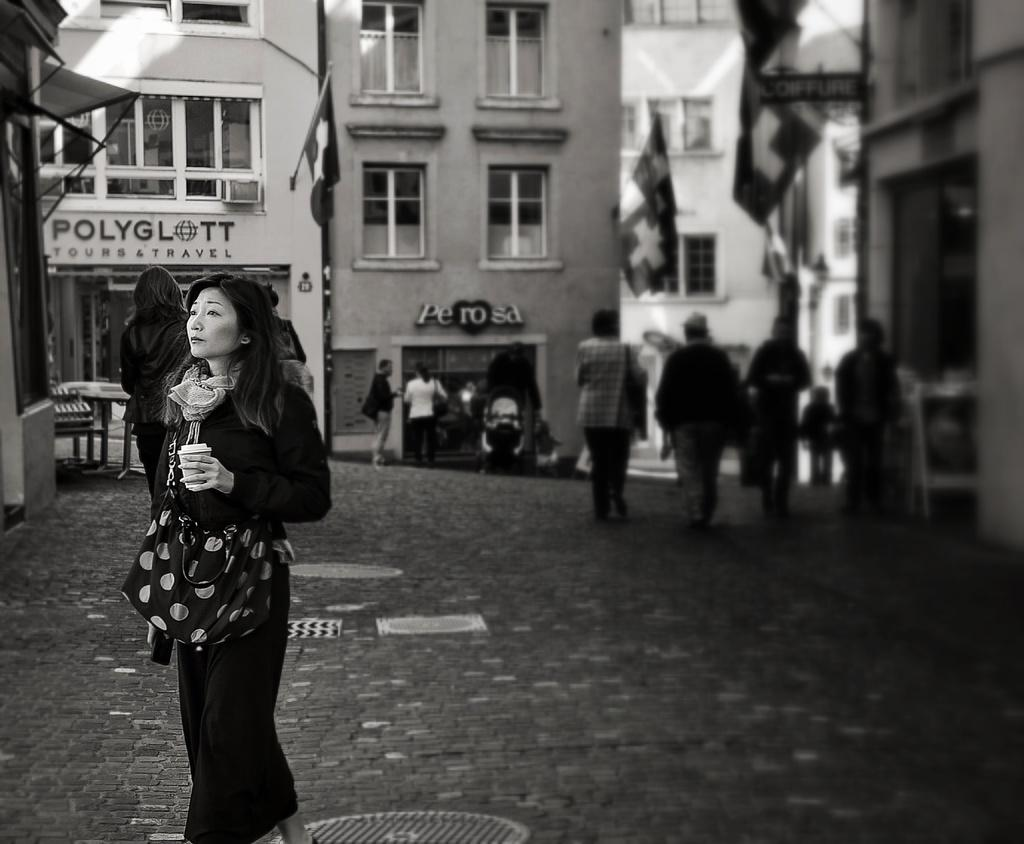Who or what can be seen in the image? There are people in the image. What structures are visible in the image? There are buildings in the image. Are there any symbols or decorations present in the image? Yes, there are flags in the image. What architectural feature can be seen in the buildings? There are windows in the image. What type of grass is being used as a tablecloth in the image? There is no grass present in the image, nor is there a tablecloth. 